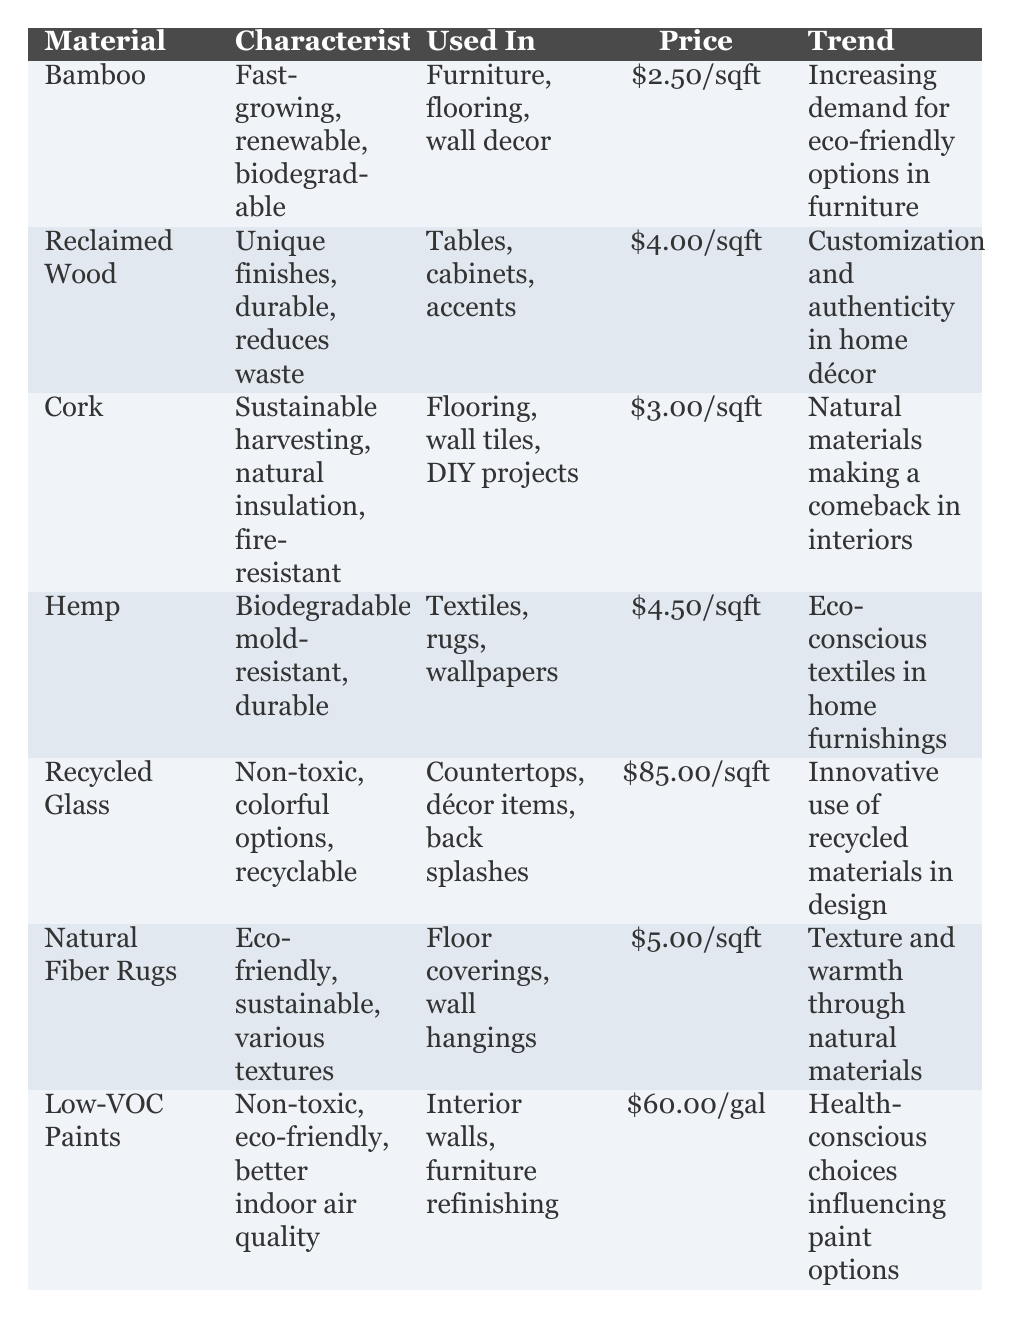What is the price per square foot of Bamboo? The table lists Bamboo's price as $2.50 per square foot, which can be directly retrieved from the "Price" column corresponding to Bamboo in the "Material" row.
Answer: $2.50/sqft Which material has the highest price per square foot? By examining the "Price" column, Recycled Glass is listed at $85.00 per square foot, which is the highest value compared to all other materials.
Answer: Recycled Glass Is Cork used in wall decor? The table specifies that Cork is used in "Flooring, wall tiles, DIY projects," and it does not mention wall decor, so the answer is no.
Answer: No What are the characteristics of Natural Fiber Rugs? The characteristics of Natural Fiber Rugs are provided in the table as "Eco-friendly, sustainable, various textures." This information can be found in the "Characteristics" column under the corresponding "Material" row.
Answer: Eco-friendly, sustainable, various textures What is the average price per square foot of all materials except Recycled Glass? First, sum the prices of the other six materials: Bamboo ($2.50), Reclaimed Wood ($4.00), Cork ($3.00), Hemp ($4.50), Natural Fiber Rugs ($5.00), and Low-VOC Paints (note: converted to square foot by treating as $0.1667 for calculation) which gives $2.50 + $4.00 + $3.00 + $4.50 + $5.00 + $0.1667 = $19.1167. There are 6 materials, so average = $19.1167 / 6 = $3.19 approx.
Answer: $3.19/sqft What is the trend associated with Reclaimed Wood? The table states that the trend associated with Reclaimed Wood is "Customization and authenticity in home décor," as visible in the "Trend" column for that specific material.
Answer: Customization and authenticity in home décor Which materials are characterized as biodegradable? The materials identified in the table as biodegradable are Bamboo and Hemp. Bamboo is noted for being fast-growing and biodegradable, while Hemp is described as biodegradable and mold-resistant. Each characteristic can be found under the respective materials in the "Characteristics" column.
Answer: Bamboo, Hemp What is the combined cost per square foot of Cork and Hemp? Combine the price per square foot of Cork ($3.00) and Hemp ($4.50). $3.00 + $4.50 = $7.50. This simple addition verifies the costs of both materials immediately.
Answer: $7.50/sqft Is there a trend for Low-VOC Paints related to health-conscious choices? According to the table, the trend for Low-VOC Paints is "Health-conscious choices influencing paint options," confirming it relates directly to health-conscious decisions.
Answer: Yes 